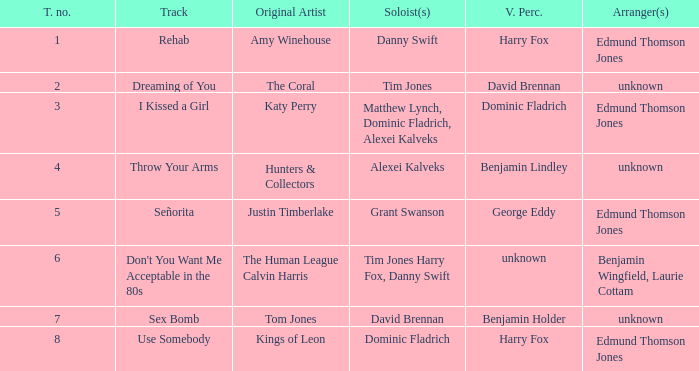Who is the percussionist for The Coral? David Brennan. 